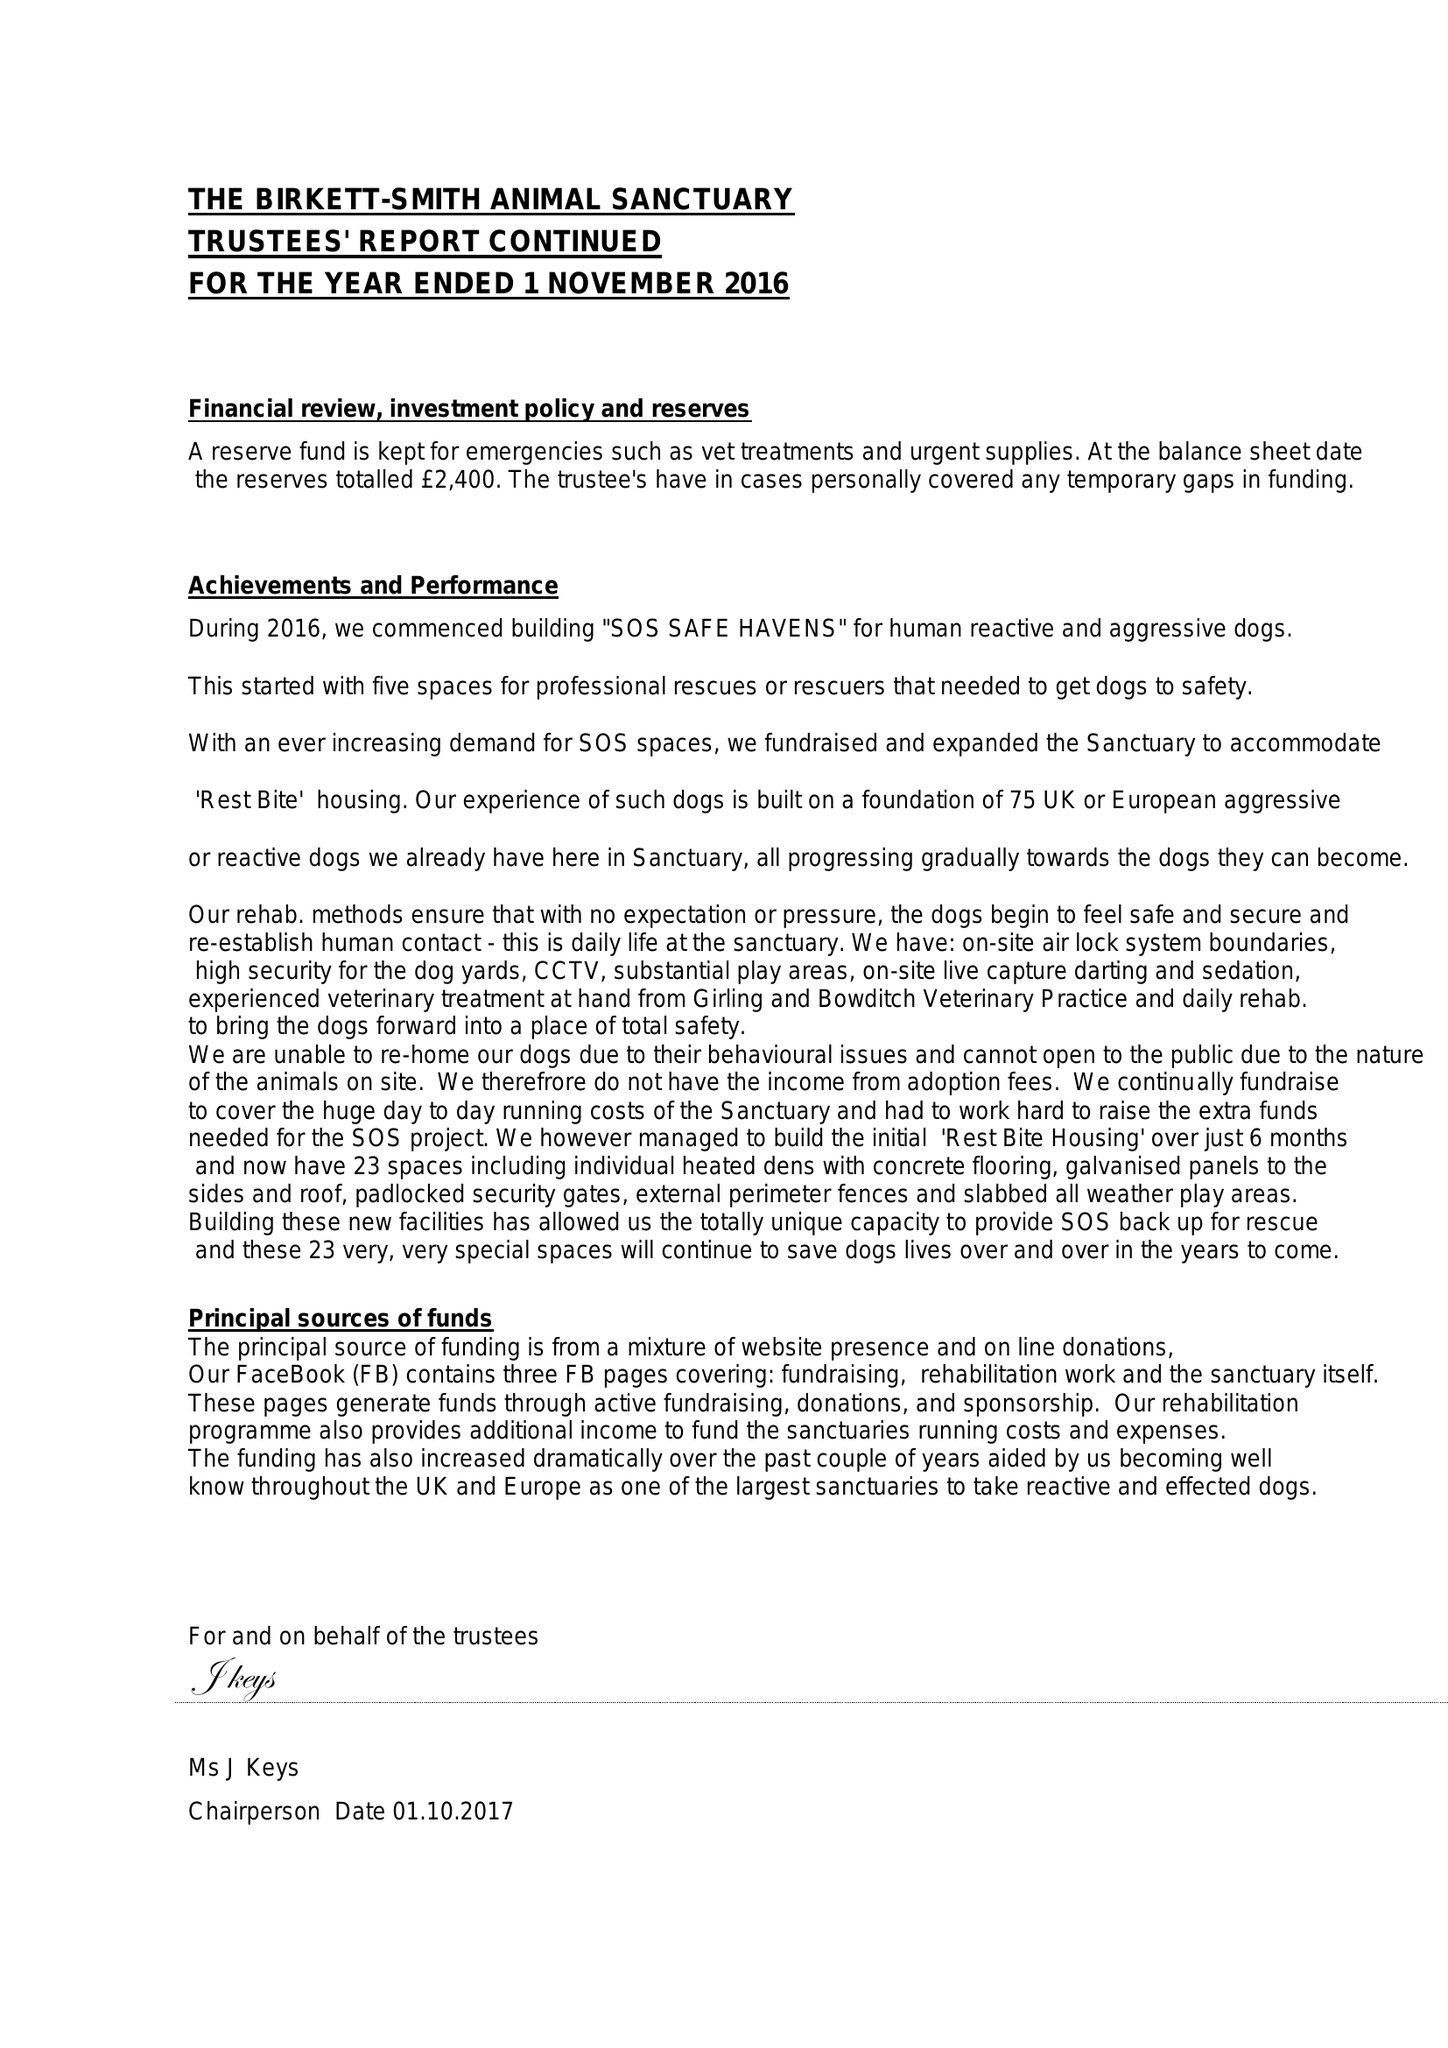What is the value for the charity_number?
Answer the question using a single word or phrase. 1152016 